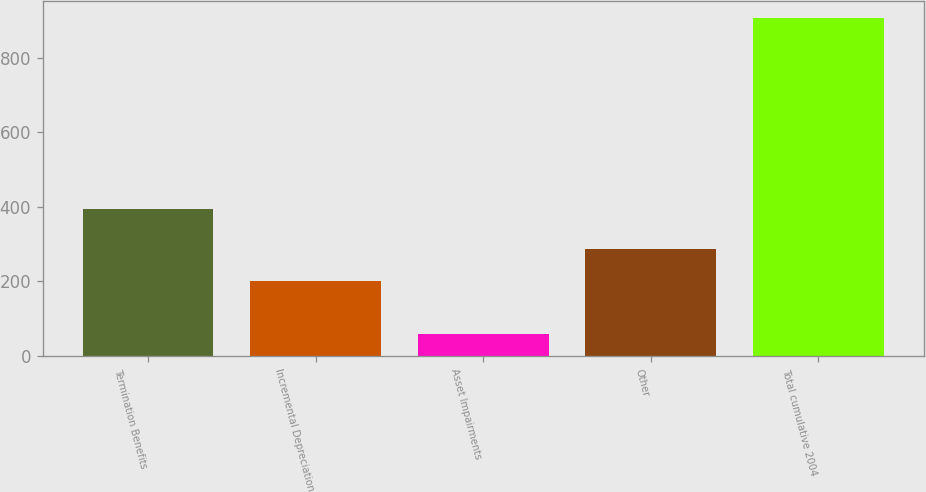Convert chart to OTSL. <chart><loc_0><loc_0><loc_500><loc_500><bar_chart><fcel>Termination Benefits<fcel>Incremental Depreciation<fcel>Asset Impairments<fcel>Other<fcel>Total cumulative 2004<nl><fcel>393.8<fcel>201.5<fcel>59.1<fcel>286.13<fcel>905.4<nl></chart> 